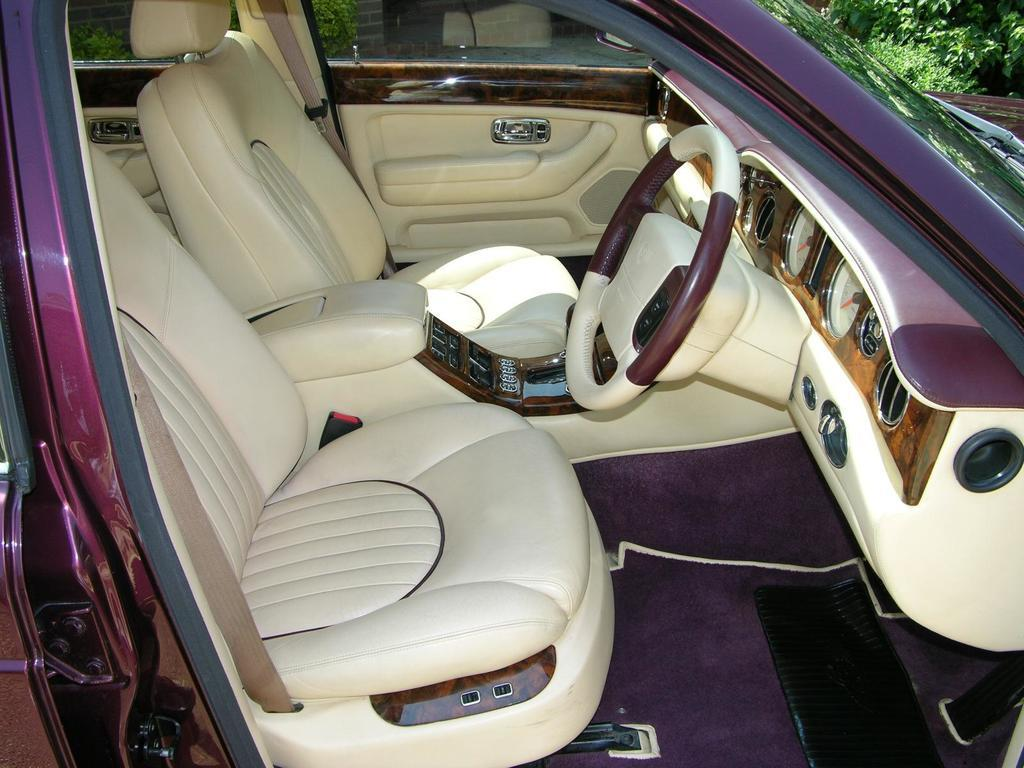What type of vehicle is in the foreground of the image? There is a purple car in the foreground of the image. How many seats are in the car? The car has two seats. What is used to control the direction of the car? The car has a steering wheel. What is present on the floor of the car? The car has a mat. What is used to measure speed and distance in the car? The car has meters. How can a person enter or exit the car? The car has a door. What type of natural environment can be seen in the image? There is greenery visible on the right top of the image. What type of scarecrow is standing next to the car in the image? There is no scarecrow present in the image; it features a purple car with various details. 